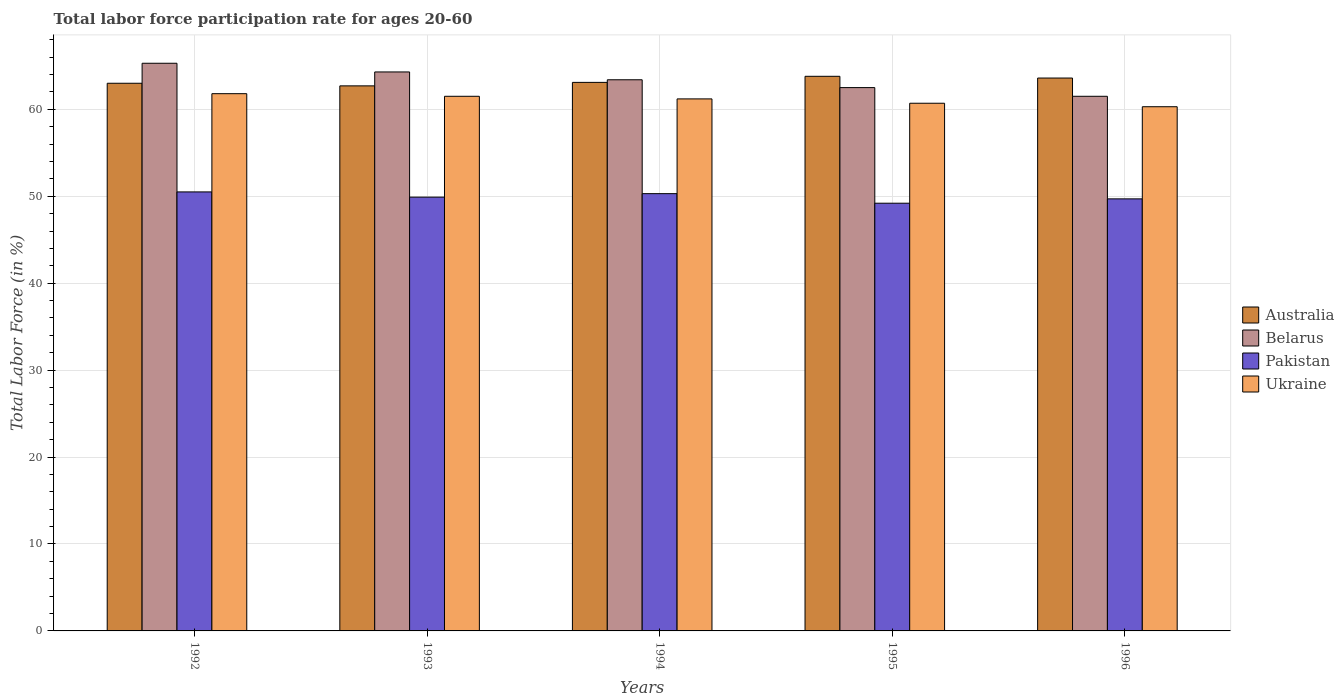How many different coloured bars are there?
Provide a succinct answer. 4. How many groups of bars are there?
Your response must be concise. 5. Are the number of bars per tick equal to the number of legend labels?
Make the answer very short. Yes. Are the number of bars on each tick of the X-axis equal?
Your response must be concise. Yes. How many bars are there on the 4th tick from the left?
Make the answer very short. 4. What is the label of the 1st group of bars from the left?
Provide a short and direct response. 1992. What is the labor force participation rate in Australia in 1996?
Offer a very short reply. 63.6. Across all years, what is the maximum labor force participation rate in Belarus?
Offer a very short reply. 65.3. Across all years, what is the minimum labor force participation rate in Ukraine?
Your answer should be very brief. 60.3. What is the total labor force participation rate in Belarus in the graph?
Your answer should be very brief. 317. What is the difference between the labor force participation rate in Belarus in 1992 and that in 1993?
Offer a very short reply. 1. What is the difference between the labor force participation rate in Pakistan in 1994 and the labor force participation rate in Belarus in 1995?
Your answer should be compact. -12.2. What is the average labor force participation rate in Ukraine per year?
Give a very brief answer. 61.1. In the year 1992, what is the difference between the labor force participation rate in Pakistan and labor force participation rate in Belarus?
Your answer should be very brief. -14.8. In how many years, is the labor force participation rate in Ukraine greater than 54 %?
Your answer should be compact. 5. What is the ratio of the labor force participation rate in Pakistan in 1992 to that in 1993?
Your answer should be very brief. 1.01. What is the difference between the highest and the second highest labor force participation rate in Pakistan?
Keep it short and to the point. 0.2. What is the difference between the highest and the lowest labor force participation rate in Belarus?
Offer a terse response. 3.8. In how many years, is the labor force participation rate in Ukraine greater than the average labor force participation rate in Ukraine taken over all years?
Your answer should be compact. 3. Is the sum of the labor force participation rate in Australia in 1992 and 1993 greater than the maximum labor force participation rate in Belarus across all years?
Provide a short and direct response. Yes. What does the 4th bar from the left in 1992 represents?
Your answer should be very brief. Ukraine. How many bars are there?
Your response must be concise. 20. Are all the bars in the graph horizontal?
Provide a short and direct response. No. How many years are there in the graph?
Keep it short and to the point. 5. Are the values on the major ticks of Y-axis written in scientific E-notation?
Your answer should be very brief. No. Does the graph contain any zero values?
Make the answer very short. No. Does the graph contain grids?
Offer a terse response. Yes. How many legend labels are there?
Your answer should be very brief. 4. How are the legend labels stacked?
Offer a very short reply. Vertical. What is the title of the graph?
Make the answer very short. Total labor force participation rate for ages 20-60. What is the Total Labor Force (in %) of Australia in 1992?
Make the answer very short. 63. What is the Total Labor Force (in %) of Belarus in 1992?
Give a very brief answer. 65.3. What is the Total Labor Force (in %) in Pakistan in 1992?
Keep it short and to the point. 50.5. What is the Total Labor Force (in %) of Ukraine in 1992?
Your answer should be compact. 61.8. What is the Total Labor Force (in %) in Australia in 1993?
Your response must be concise. 62.7. What is the Total Labor Force (in %) in Belarus in 1993?
Offer a very short reply. 64.3. What is the Total Labor Force (in %) in Pakistan in 1993?
Keep it short and to the point. 49.9. What is the Total Labor Force (in %) in Ukraine in 1993?
Offer a very short reply. 61.5. What is the Total Labor Force (in %) in Australia in 1994?
Offer a terse response. 63.1. What is the Total Labor Force (in %) in Belarus in 1994?
Provide a succinct answer. 63.4. What is the Total Labor Force (in %) in Pakistan in 1994?
Offer a terse response. 50.3. What is the Total Labor Force (in %) of Ukraine in 1994?
Your response must be concise. 61.2. What is the Total Labor Force (in %) in Australia in 1995?
Provide a succinct answer. 63.8. What is the Total Labor Force (in %) of Belarus in 1995?
Provide a succinct answer. 62.5. What is the Total Labor Force (in %) of Pakistan in 1995?
Provide a short and direct response. 49.2. What is the Total Labor Force (in %) of Ukraine in 1995?
Provide a short and direct response. 60.7. What is the Total Labor Force (in %) in Australia in 1996?
Keep it short and to the point. 63.6. What is the Total Labor Force (in %) of Belarus in 1996?
Make the answer very short. 61.5. What is the Total Labor Force (in %) in Pakistan in 1996?
Your response must be concise. 49.7. What is the Total Labor Force (in %) in Ukraine in 1996?
Make the answer very short. 60.3. Across all years, what is the maximum Total Labor Force (in %) in Australia?
Your answer should be compact. 63.8. Across all years, what is the maximum Total Labor Force (in %) in Belarus?
Offer a terse response. 65.3. Across all years, what is the maximum Total Labor Force (in %) of Pakistan?
Ensure brevity in your answer.  50.5. Across all years, what is the maximum Total Labor Force (in %) of Ukraine?
Make the answer very short. 61.8. Across all years, what is the minimum Total Labor Force (in %) in Australia?
Keep it short and to the point. 62.7. Across all years, what is the minimum Total Labor Force (in %) of Belarus?
Make the answer very short. 61.5. Across all years, what is the minimum Total Labor Force (in %) of Pakistan?
Offer a terse response. 49.2. Across all years, what is the minimum Total Labor Force (in %) in Ukraine?
Your answer should be very brief. 60.3. What is the total Total Labor Force (in %) in Australia in the graph?
Keep it short and to the point. 316.2. What is the total Total Labor Force (in %) in Belarus in the graph?
Provide a short and direct response. 317. What is the total Total Labor Force (in %) of Pakistan in the graph?
Your answer should be compact. 249.6. What is the total Total Labor Force (in %) in Ukraine in the graph?
Give a very brief answer. 305.5. What is the difference between the Total Labor Force (in %) of Ukraine in 1992 and that in 1993?
Provide a succinct answer. 0.3. What is the difference between the Total Labor Force (in %) of Australia in 1992 and that in 1994?
Your response must be concise. -0.1. What is the difference between the Total Labor Force (in %) in Ukraine in 1992 and that in 1994?
Ensure brevity in your answer.  0.6. What is the difference between the Total Labor Force (in %) in Belarus in 1992 and that in 1995?
Ensure brevity in your answer.  2.8. What is the difference between the Total Labor Force (in %) of Pakistan in 1992 and that in 1995?
Your answer should be compact. 1.3. What is the difference between the Total Labor Force (in %) of Ukraine in 1992 and that in 1995?
Your response must be concise. 1.1. What is the difference between the Total Labor Force (in %) of Australia in 1992 and that in 1996?
Make the answer very short. -0.6. What is the difference between the Total Labor Force (in %) of Belarus in 1993 and that in 1994?
Make the answer very short. 0.9. What is the difference between the Total Labor Force (in %) in Ukraine in 1993 and that in 1995?
Keep it short and to the point. 0.8. What is the difference between the Total Labor Force (in %) in Australia in 1993 and that in 1996?
Keep it short and to the point. -0.9. What is the difference between the Total Labor Force (in %) of Belarus in 1993 and that in 1996?
Make the answer very short. 2.8. What is the difference between the Total Labor Force (in %) of Australia in 1994 and that in 1995?
Offer a terse response. -0.7. What is the difference between the Total Labor Force (in %) in Pakistan in 1994 and that in 1995?
Offer a terse response. 1.1. What is the difference between the Total Labor Force (in %) in Ukraine in 1994 and that in 1995?
Make the answer very short. 0.5. What is the difference between the Total Labor Force (in %) of Australia in 1994 and that in 1996?
Make the answer very short. -0.5. What is the difference between the Total Labor Force (in %) in Belarus in 1994 and that in 1996?
Offer a terse response. 1.9. What is the difference between the Total Labor Force (in %) in Pakistan in 1994 and that in 1996?
Make the answer very short. 0.6. What is the difference between the Total Labor Force (in %) in Ukraine in 1994 and that in 1996?
Offer a very short reply. 0.9. What is the difference between the Total Labor Force (in %) in Pakistan in 1995 and that in 1996?
Give a very brief answer. -0.5. What is the difference between the Total Labor Force (in %) of Belarus in 1992 and the Total Labor Force (in %) of Ukraine in 1993?
Provide a succinct answer. 3.8. What is the difference between the Total Labor Force (in %) of Australia in 1992 and the Total Labor Force (in %) of Belarus in 1994?
Your answer should be very brief. -0.4. What is the difference between the Total Labor Force (in %) of Belarus in 1992 and the Total Labor Force (in %) of Pakistan in 1994?
Your answer should be very brief. 15. What is the difference between the Total Labor Force (in %) in Pakistan in 1992 and the Total Labor Force (in %) in Ukraine in 1994?
Provide a short and direct response. -10.7. What is the difference between the Total Labor Force (in %) in Australia in 1992 and the Total Labor Force (in %) in Pakistan in 1995?
Your answer should be very brief. 13.8. What is the difference between the Total Labor Force (in %) of Australia in 1992 and the Total Labor Force (in %) of Ukraine in 1995?
Give a very brief answer. 2.3. What is the difference between the Total Labor Force (in %) in Belarus in 1992 and the Total Labor Force (in %) in Pakistan in 1995?
Your answer should be very brief. 16.1. What is the difference between the Total Labor Force (in %) of Pakistan in 1992 and the Total Labor Force (in %) of Ukraine in 1995?
Ensure brevity in your answer.  -10.2. What is the difference between the Total Labor Force (in %) of Pakistan in 1992 and the Total Labor Force (in %) of Ukraine in 1996?
Keep it short and to the point. -9.8. What is the difference between the Total Labor Force (in %) of Australia in 1993 and the Total Labor Force (in %) of Ukraine in 1994?
Your answer should be compact. 1.5. What is the difference between the Total Labor Force (in %) in Belarus in 1993 and the Total Labor Force (in %) in Pakistan in 1994?
Make the answer very short. 14. What is the difference between the Total Labor Force (in %) in Pakistan in 1993 and the Total Labor Force (in %) in Ukraine in 1994?
Provide a succinct answer. -11.3. What is the difference between the Total Labor Force (in %) in Australia in 1993 and the Total Labor Force (in %) in Belarus in 1995?
Your answer should be very brief. 0.2. What is the difference between the Total Labor Force (in %) of Australia in 1993 and the Total Labor Force (in %) of Pakistan in 1995?
Ensure brevity in your answer.  13.5. What is the difference between the Total Labor Force (in %) in Belarus in 1993 and the Total Labor Force (in %) in Pakistan in 1995?
Make the answer very short. 15.1. What is the difference between the Total Labor Force (in %) of Australia in 1993 and the Total Labor Force (in %) of Pakistan in 1996?
Offer a very short reply. 13. What is the difference between the Total Labor Force (in %) in Australia in 1993 and the Total Labor Force (in %) in Ukraine in 1996?
Provide a short and direct response. 2.4. What is the difference between the Total Labor Force (in %) in Belarus in 1993 and the Total Labor Force (in %) in Pakistan in 1996?
Ensure brevity in your answer.  14.6. What is the difference between the Total Labor Force (in %) in Belarus in 1993 and the Total Labor Force (in %) in Ukraine in 1996?
Your answer should be compact. 4. What is the difference between the Total Labor Force (in %) of Australia in 1994 and the Total Labor Force (in %) of Pakistan in 1995?
Give a very brief answer. 13.9. What is the difference between the Total Labor Force (in %) of Australia in 1994 and the Total Labor Force (in %) of Ukraine in 1995?
Your answer should be very brief. 2.4. What is the difference between the Total Labor Force (in %) of Belarus in 1994 and the Total Labor Force (in %) of Pakistan in 1995?
Offer a terse response. 14.2. What is the difference between the Total Labor Force (in %) in Belarus in 1994 and the Total Labor Force (in %) in Ukraine in 1995?
Make the answer very short. 2.7. What is the difference between the Total Labor Force (in %) in Australia in 1994 and the Total Labor Force (in %) in Pakistan in 1996?
Provide a succinct answer. 13.4. What is the difference between the Total Labor Force (in %) of Belarus in 1994 and the Total Labor Force (in %) of Ukraine in 1996?
Offer a terse response. 3.1. What is the difference between the Total Labor Force (in %) in Pakistan in 1994 and the Total Labor Force (in %) in Ukraine in 1996?
Make the answer very short. -10. What is the difference between the Total Labor Force (in %) of Australia in 1995 and the Total Labor Force (in %) of Pakistan in 1996?
Give a very brief answer. 14.1. What is the difference between the Total Labor Force (in %) of Australia in 1995 and the Total Labor Force (in %) of Ukraine in 1996?
Keep it short and to the point. 3.5. What is the difference between the Total Labor Force (in %) in Belarus in 1995 and the Total Labor Force (in %) in Pakistan in 1996?
Give a very brief answer. 12.8. What is the difference between the Total Labor Force (in %) in Pakistan in 1995 and the Total Labor Force (in %) in Ukraine in 1996?
Your response must be concise. -11.1. What is the average Total Labor Force (in %) of Australia per year?
Your answer should be compact. 63.24. What is the average Total Labor Force (in %) of Belarus per year?
Provide a succinct answer. 63.4. What is the average Total Labor Force (in %) in Pakistan per year?
Ensure brevity in your answer.  49.92. What is the average Total Labor Force (in %) in Ukraine per year?
Your answer should be very brief. 61.1. In the year 1992, what is the difference between the Total Labor Force (in %) in Australia and Total Labor Force (in %) in Pakistan?
Provide a short and direct response. 12.5. In the year 1992, what is the difference between the Total Labor Force (in %) in Australia and Total Labor Force (in %) in Ukraine?
Your answer should be very brief. 1.2. In the year 1992, what is the difference between the Total Labor Force (in %) of Belarus and Total Labor Force (in %) of Pakistan?
Your response must be concise. 14.8. In the year 1992, what is the difference between the Total Labor Force (in %) in Belarus and Total Labor Force (in %) in Ukraine?
Your answer should be compact. 3.5. In the year 1993, what is the difference between the Total Labor Force (in %) of Australia and Total Labor Force (in %) of Pakistan?
Your response must be concise. 12.8. In the year 1993, what is the difference between the Total Labor Force (in %) in Australia and Total Labor Force (in %) in Ukraine?
Give a very brief answer. 1.2. In the year 1993, what is the difference between the Total Labor Force (in %) in Belarus and Total Labor Force (in %) in Ukraine?
Keep it short and to the point. 2.8. In the year 1994, what is the difference between the Total Labor Force (in %) in Australia and Total Labor Force (in %) in Belarus?
Keep it short and to the point. -0.3. In the year 1994, what is the difference between the Total Labor Force (in %) in Australia and Total Labor Force (in %) in Ukraine?
Offer a terse response. 1.9. In the year 1995, what is the difference between the Total Labor Force (in %) of Australia and Total Labor Force (in %) of Belarus?
Offer a terse response. 1.3. In the year 1995, what is the difference between the Total Labor Force (in %) of Belarus and Total Labor Force (in %) of Ukraine?
Offer a very short reply. 1.8. In the year 1996, what is the difference between the Total Labor Force (in %) of Australia and Total Labor Force (in %) of Belarus?
Provide a succinct answer. 2.1. In the year 1996, what is the difference between the Total Labor Force (in %) of Australia and Total Labor Force (in %) of Pakistan?
Provide a short and direct response. 13.9. In the year 1996, what is the difference between the Total Labor Force (in %) of Belarus and Total Labor Force (in %) of Pakistan?
Your response must be concise. 11.8. In the year 1996, what is the difference between the Total Labor Force (in %) of Belarus and Total Labor Force (in %) of Ukraine?
Provide a succinct answer. 1.2. In the year 1996, what is the difference between the Total Labor Force (in %) of Pakistan and Total Labor Force (in %) of Ukraine?
Provide a short and direct response. -10.6. What is the ratio of the Total Labor Force (in %) in Belarus in 1992 to that in 1993?
Your answer should be very brief. 1.02. What is the ratio of the Total Labor Force (in %) in Pakistan in 1992 to that in 1993?
Offer a very short reply. 1.01. What is the ratio of the Total Labor Force (in %) in Ukraine in 1992 to that in 1993?
Your answer should be compact. 1. What is the ratio of the Total Labor Force (in %) in Australia in 1992 to that in 1994?
Your answer should be very brief. 1. What is the ratio of the Total Labor Force (in %) in Belarus in 1992 to that in 1994?
Give a very brief answer. 1.03. What is the ratio of the Total Labor Force (in %) in Pakistan in 1992 to that in 1994?
Keep it short and to the point. 1. What is the ratio of the Total Labor Force (in %) in Ukraine in 1992 to that in 1994?
Offer a very short reply. 1.01. What is the ratio of the Total Labor Force (in %) of Australia in 1992 to that in 1995?
Your response must be concise. 0.99. What is the ratio of the Total Labor Force (in %) in Belarus in 1992 to that in 1995?
Your response must be concise. 1.04. What is the ratio of the Total Labor Force (in %) of Pakistan in 1992 to that in 1995?
Provide a short and direct response. 1.03. What is the ratio of the Total Labor Force (in %) in Ukraine in 1992 to that in 1995?
Offer a terse response. 1.02. What is the ratio of the Total Labor Force (in %) in Australia in 1992 to that in 1996?
Ensure brevity in your answer.  0.99. What is the ratio of the Total Labor Force (in %) in Belarus in 1992 to that in 1996?
Provide a succinct answer. 1.06. What is the ratio of the Total Labor Force (in %) of Pakistan in 1992 to that in 1996?
Provide a succinct answer. 1.02. What is the ratio of the Total Labor Force (in %) in Ukraine in 1992 to that in 1996?
Offer a terse response. 1.02. What is the ratio of the Total Labor Force (in %) of Australia in 1993 to that in 1994?
Keep it short and to the point. 0.99. What is the ratio of the Total Labor Force (in %) of Belarus in 1993 to that in 1994?
Keep it short and to the point. 1.01. What is the ratio of the Total Labor Force (in %) in Australia in 1993 to that in 1995?
Offer a very short reply. 0.98. What is the ratio of the Total Labor Force (in %) of Belarus in 1993 to that in 1995?
Your answer should be very brief. 1.03. What is the ratio of the Total Labor Force (in %) of Pakistan in 1993 to that in 1995?
Ensure brevity in your answer.  1.01. What is the ratio of the Total Labor Force (in %) of Ukraine in 1993 to that in 1995?
Offer a very short reply. 1.01. What is the ratio of the Total Labor Force (in %) in Australia in 1993 to that in 1996?
Give a very brief answer. 0.99. What is the ratio of the Total Labor Force (in %) of Belarus in 1993 to that in 1996?
Your answer should be compact. 1.05. What is the ratio of the Total Labor Force (in %) in Ukraine in 1993 to that in 1996?
Offer a very short reply. 1.02. What is the ratio of the Total Labor Force (in %) in Australia in 1994 to that in 1995?
Provide a short and direct response. 0.99. What is the ratio of the Total Labor Force (in %) in Belarus in 1994 to that in 1995?
Your response must be concise. 1.01. What is the ratio of the Total Labor Force (in %) of Pakistan in 1994 to that in 1995?
Your answer should be very brief. 1.02. What is the ratio of the Total Labor Force (in %) of Ukraine in 1994 to that in 1995?
Your answer should be compact. 1.01. What is the ratio of the Total Labor Force (in %) of Australia in 1994 to that in 1996?
Your response must be concise. 0.99. What is the ratio of the Total Labor Force (in %) in Belarus in 1994 to that in 1996?
Your answer should be compact. 1.03. What is the ratio of the Total Labor Force (in %) of Pakistan in 1994 to that in 1996?
Offer a terse response. 1.01. What is the ratio of the Total Labor Force (in %) in Ukraine in 1994 to that in 1996?
Your answer should be compact. 1.01. What is the ratio of the Total Labor Force (in %) of Belarus in 1995 to that in 1996?
Provide a short and direct response. 1.02. What is the ratio of the Total Labor Force (in %) of Ukraine in 1995 to that in 1996?
Offer a very short reply. 1.01. What is the difference between the highest and the second highest Total Labor Force (in %) of Belarus?
Offer a very short reply. 1. What is the difference between the highest and the second highest Total Labor Force (in %) of Pakistan?
Provide a succinct answer. 0.2. What is the difference between the highest and the lowest Total Labor Force (in %) in Australia?
Ensure brevity in your answer.  1.1. What is the difference between the highest and the lowest Total Labor Force (in %) in Belarus?
Keep it short and to the point. 3.8. What is the difference between the highest and the lowest Total Labor Force (in %) of Pakistan?
Keep it short and to the point. 1.3. 